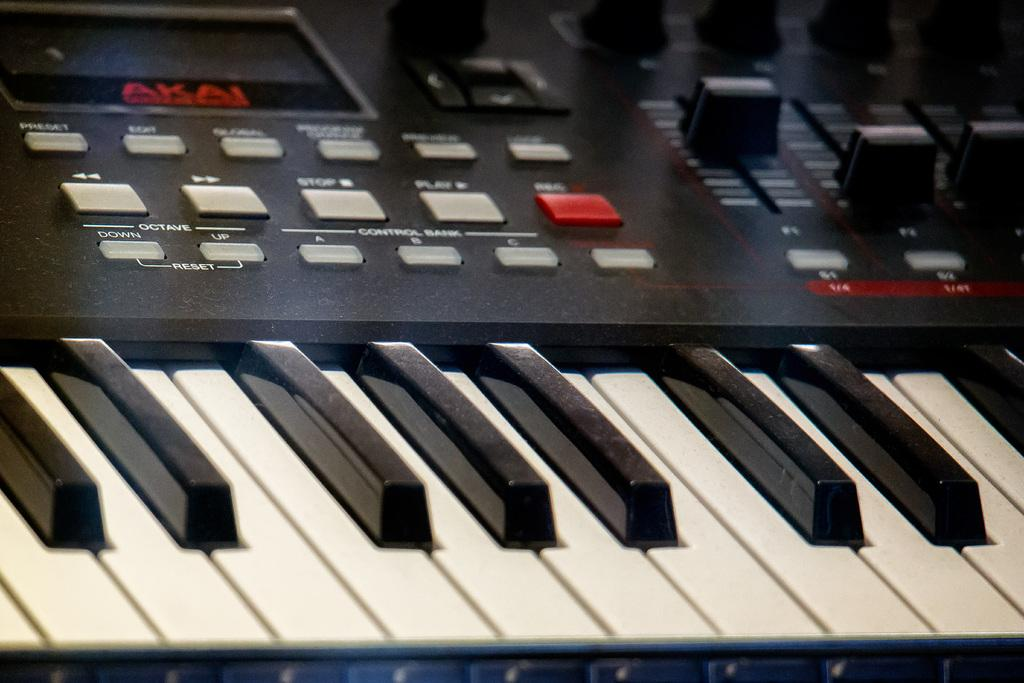<image>
Create a compact narrative representing the image presented. Akai is in red letters above the keyboard. 